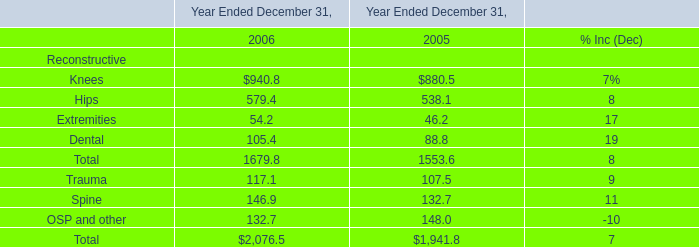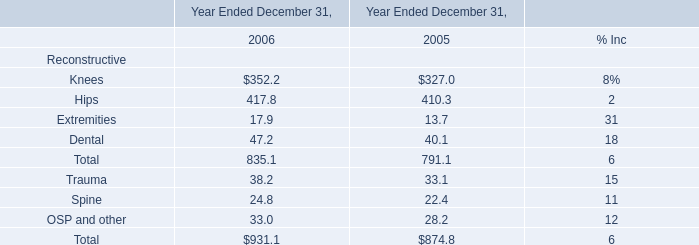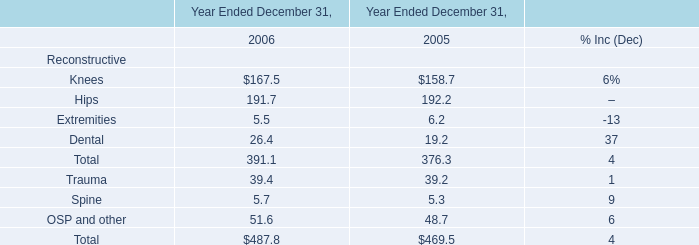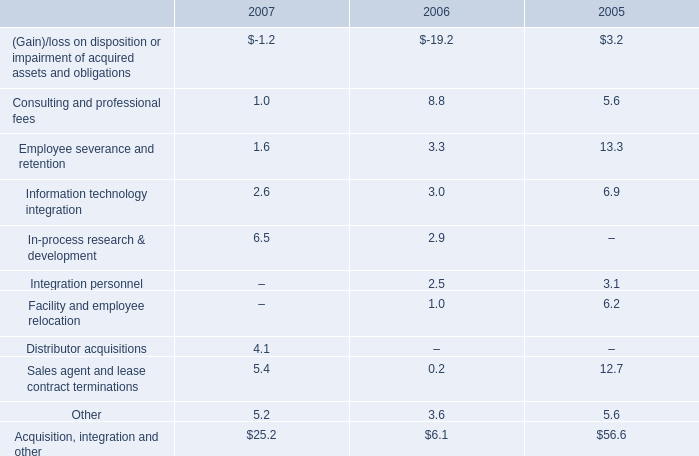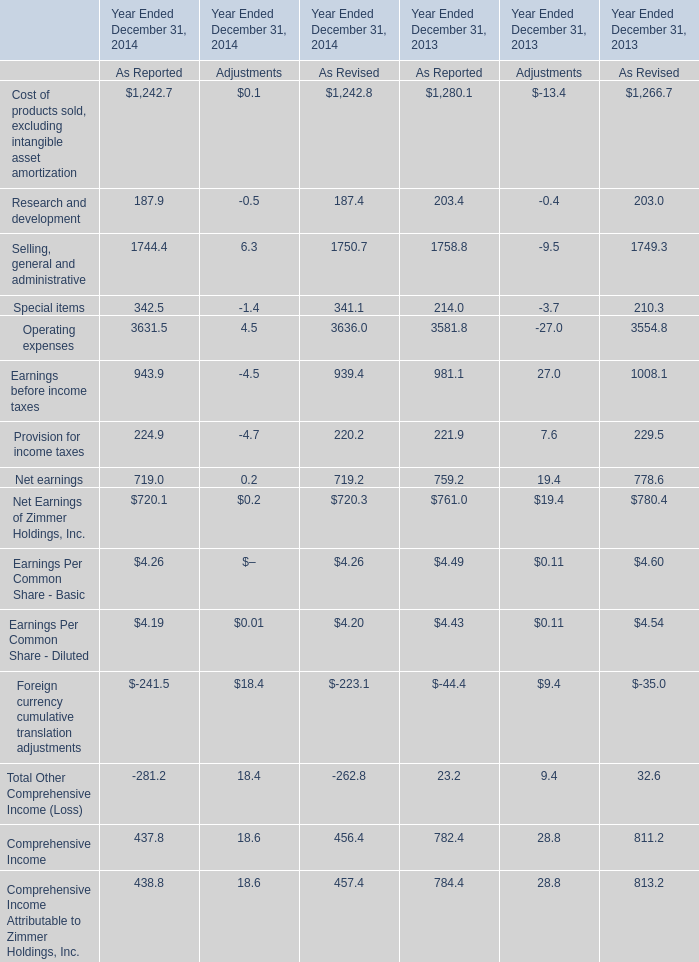As As the chart 4 shows, for Year Ended December 31,which year is the value As Reported of the Operating expenses higher ? 
Answer: 2014. 